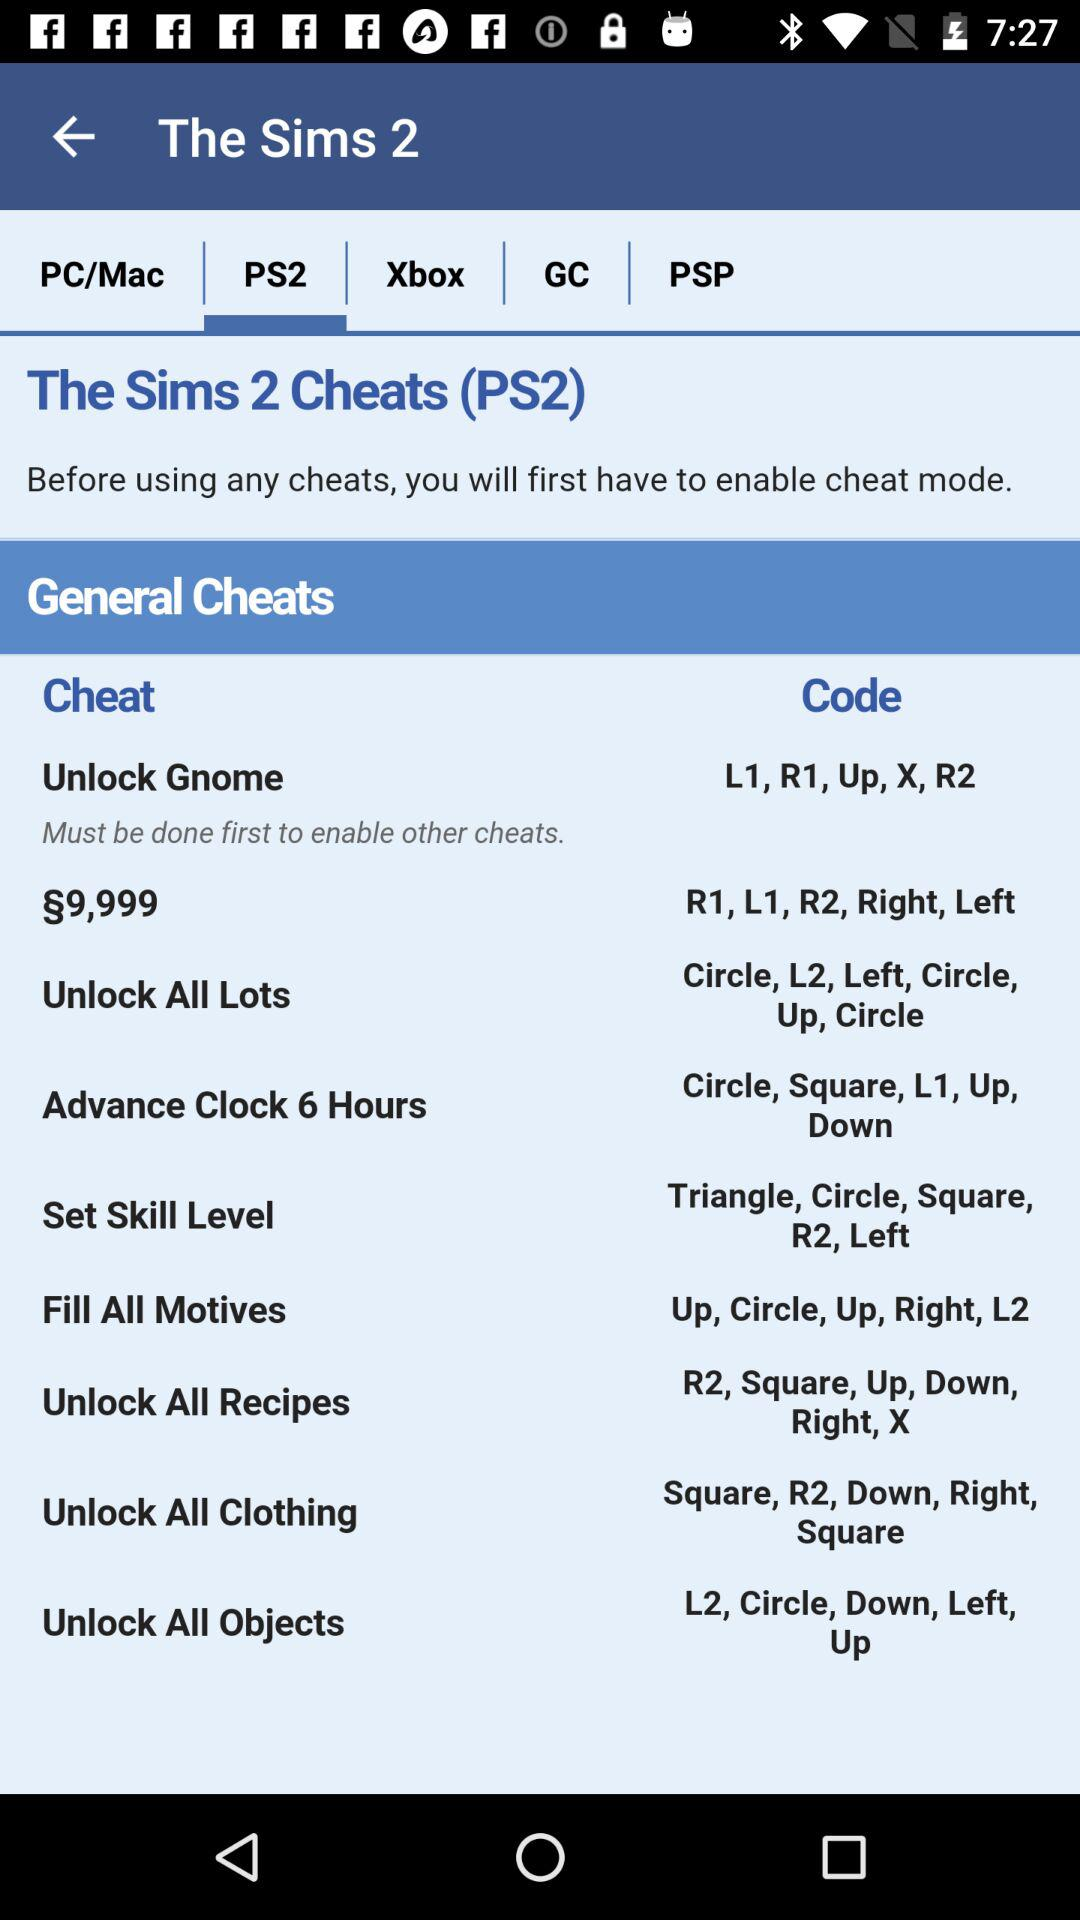For what is the code "Up, Circle, Up, Right, L2" used? The code is used for "Fill All Motives". 